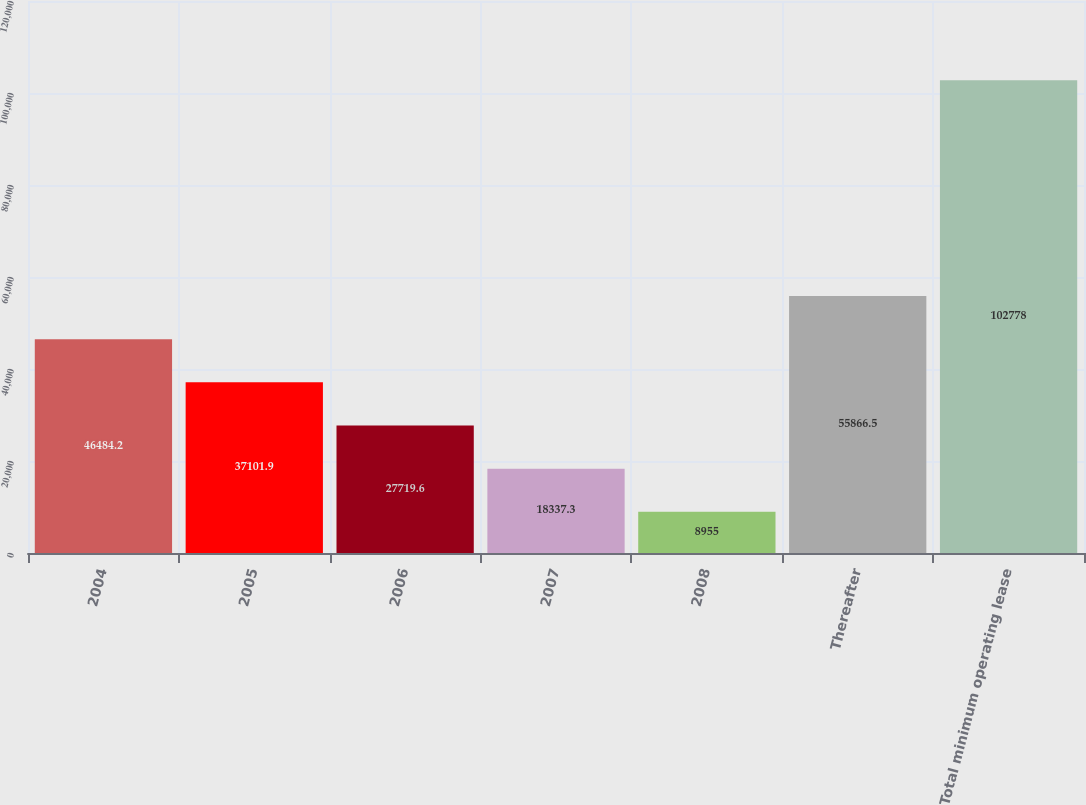Convert chart to OTSL. <chart><loc_0><loc_0><loc_500><loc_500><bar_chart><fcel>2004<fcel>2005<fcel>2006<fcel>2007<fcel>2008<fcel>Thereafter<fcel>Total minimum operating lease<nl><fcel>46484.2<fcel>37101.9<fcel>27719.6<fcel>18337.3<fcel>8955<fcel>55866.5<fcel>102778<nl></chart> 